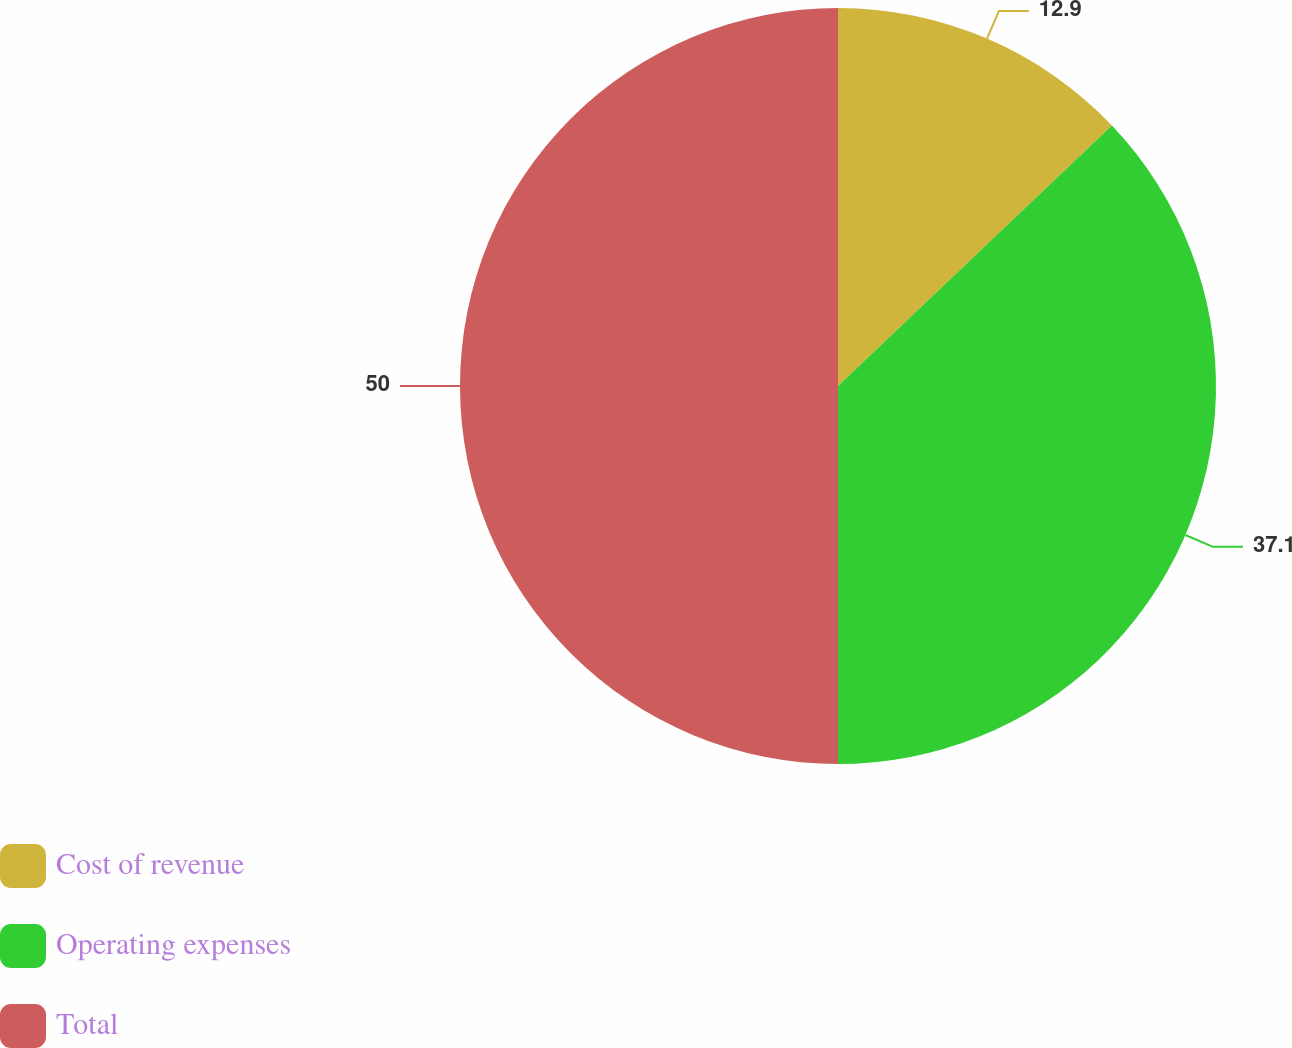Convert chart to OTSL. <chart><loc_0><loc_0><loc_500><loc_500><pie_chart><fcel>Cost of revenue<fcel>Operating expenses<fcel>Total<nl><fcel>12.9%<fcel>37.1%<fcel>50.0%<nl></chart> 